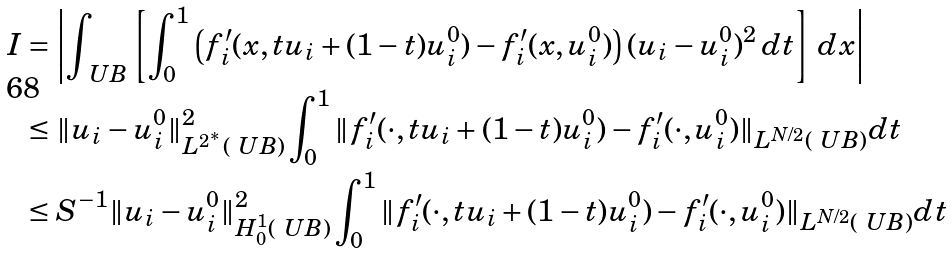<formula> <loc_0><loc_0><loc_500><loc_500>I & = \left | \int _ { \ U B } \left [ \int _ { 0 } ^ { 1 } \left ( f _ { i } ^ { \prime } ( x , t u _ { i } + ( 1 - t ) u _ { i } ^ { 0 } ) - f _ { i } ^ { \prime } ( x , u _ { i } ^ { 0 } ) \right ) ( u _ { i } - u _ { i } ^ { 0 } ) ^ { 2 } \, d t \right ] \, d x \right | \\ & \leq \| u _ { i } - u _ { i } ^ { 0 } \| _ { L ^ { 2 ^ { * } } ( \ U B ) } ^ { 2 } \int _ { 0 } ^ { 1 } \| f _ { i } ^ { \prime } ( \cdot , t u _ { i } + ( 1 - t ) u _ { i } ^ { 0 } ) - f _ { i } ^ { \prime } ( \cdot , u _ { i } ^ { 0 } ) \| _ { L ^ { N / 2 } ( \ U B ) } d t \\ & \leq S ^ { - 1 } \| u _ { i } - u _ { i } ^ { 0 } \| _ { H ^ { 1 } _ { 0 } ( \ U B ) } ^ { 2 } \int _ { 0 } ^ { 1 } \| f _ { i } ^ { \prime } ( \cdot , t u _ { i } + ( 1 - t ) u _ { i } ^ { 0 } ) - f _ { i } ^ { \prime } ( \cdot , u _ { i } ^ { 0 } ) \| _ { L ^ { N / 2 } ( \ U B ) } d t</formula> 